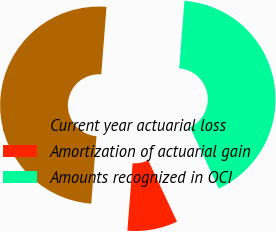<chart> <loc_0><loc_0><loc_500><loc_500><pie_chart><fcel>Current year actuarial loss<fcel>Amortization of actuarial gain<fcel>Amounts recognized in OCI<nl><fcel>50.0%<fcel>8.23%<fcel>41.77%<nl></chart> 